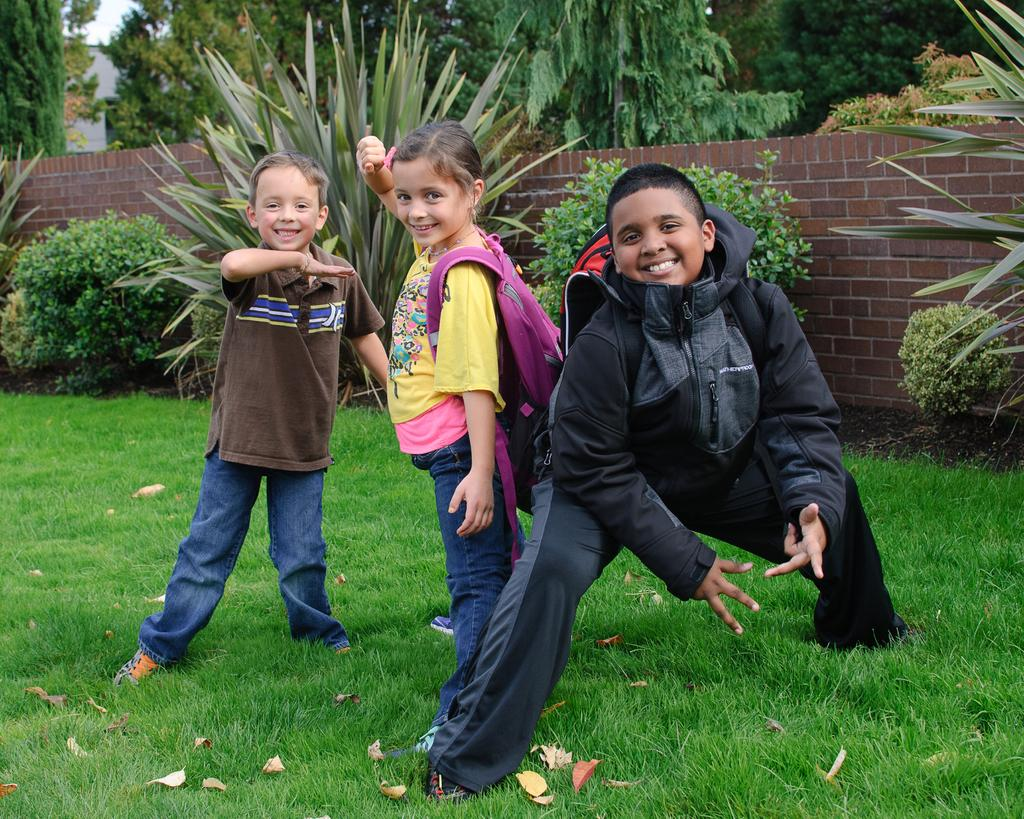How many children are in the image? There are two boys and a girl in the image. What are the children doing in the image? The children are on the grass and smiling. Which children are carrying bags in the image? There is a girl carrying a bag and a boy carrying a bag in the image. What can be seen in the background of the image? There are plants, a wall, trees, a building, and the sky visible in the background of the image. What type of lift can be seen in the image? There is no lift present in the image. How does the earth interact with the children in the image? The earth does not interact with the children in the image; it is the ground on which they are standing. 